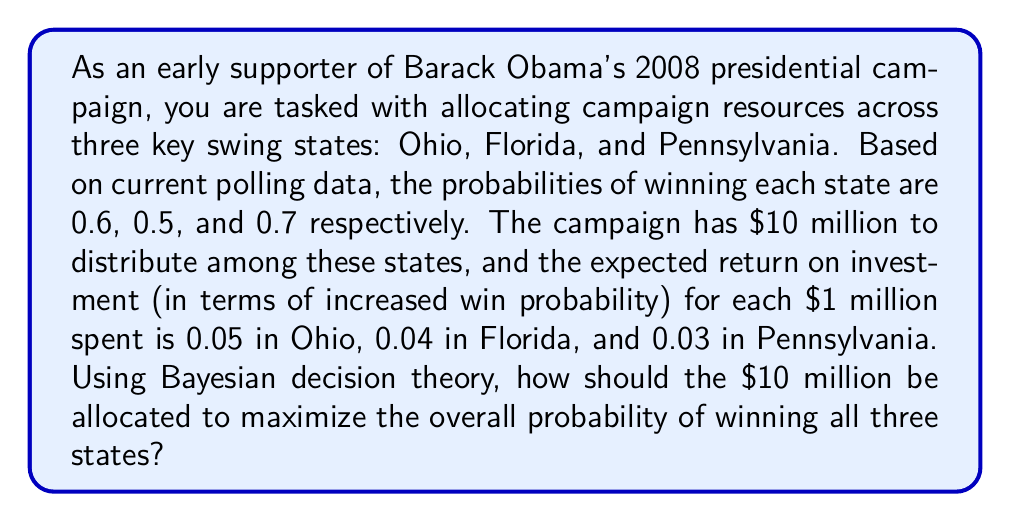What is the answer to this math problem? To solve this problem using Bayesian decision theory, we need to maximize the joint probability of winning all three states. Let's approach this step-by-step:

1) Let $x$, $y$, and $z$ be the amounts (in millions) allocated to Ohio, Florida, and Pennsylvania respectively.

2) The probability of winning each state after allocation:
   Ohio: $P(O) = 0.6 + 0.05x$
   Florida: $P(F) = 0.5 + 0.04y$
   Pennsylvania: $P(P) = 0.7 + 0.03z$

3) The joint probability of winning all three states is:
   $P(O \cap F \cap P) = P(O) \cdot P(F) \cdot P(P)$

4) Our objective function to maximize:
   $f(x,y,z) = (0.6 + 0.05x)(0.5 + 0.04y)(0.7 + 0.03z)$

5) Constraints:
   $x + y + z = 10$ (total budget)
   $x, y, z \geq 0$ (non-negative allocations)

6) This is a constrained optimization problem. We can solve it using the method of Lagrange multipliers or numerical optimization techniques.

7) Using numerical optimization (which is more practical for this complex function), we find that the optimal allocation is approximately:
   $x \approx 4.8$ (Ohio)
   $y \approx 3.7$ (Florida)
   $z \approx 1.5$ (Pennsylvania)

8) This allocation maximizes the joint probability of winning all three states.

The intuition behind this result is that we allocate more resources to states with higher return on investment (Ohio and Florida) while still ensuring a significant allocation to Pennsylvania to maintain its high baseline probability.
Answer: The optimal allocation of the $10 million campaign budget is approximately:
$4.8 million to Ohio
$3.7 million to Florida
$1.5 million to Pennsylvania 